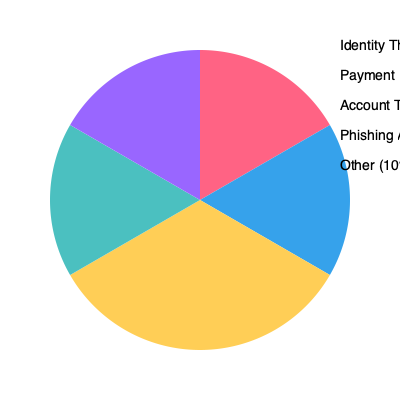Based on the pie chart showing the distribution of fraud types detected by your company's implemented measures, what is the ratio of Identity Theft cases to Phishing Attacks cases? Express your answer as a simplified fraction. To solve this problem, we need to follow these steps:

1. Identify the percentages for Identity Theft and Phishing Attacks from the pie chart:
   - Identity Theft: 30%
   - Phishing Attacks: 15%

2. Express these percentages as a ratio:
   Identity Theft : Phishing Attacks = 30 : 15

3. Simplify the ratio by dividing both numbers by their greatest common divisor (GCD):
   The GCD of 30 and 15 is 15.
   
   $\frac{30}{15} : \frac{15}{15} = 2 : 1$

Therefore, the simplified ratio of Identity Theft cases to Phishing Attacks cases is 2:1.
Answer: $2:1$ 